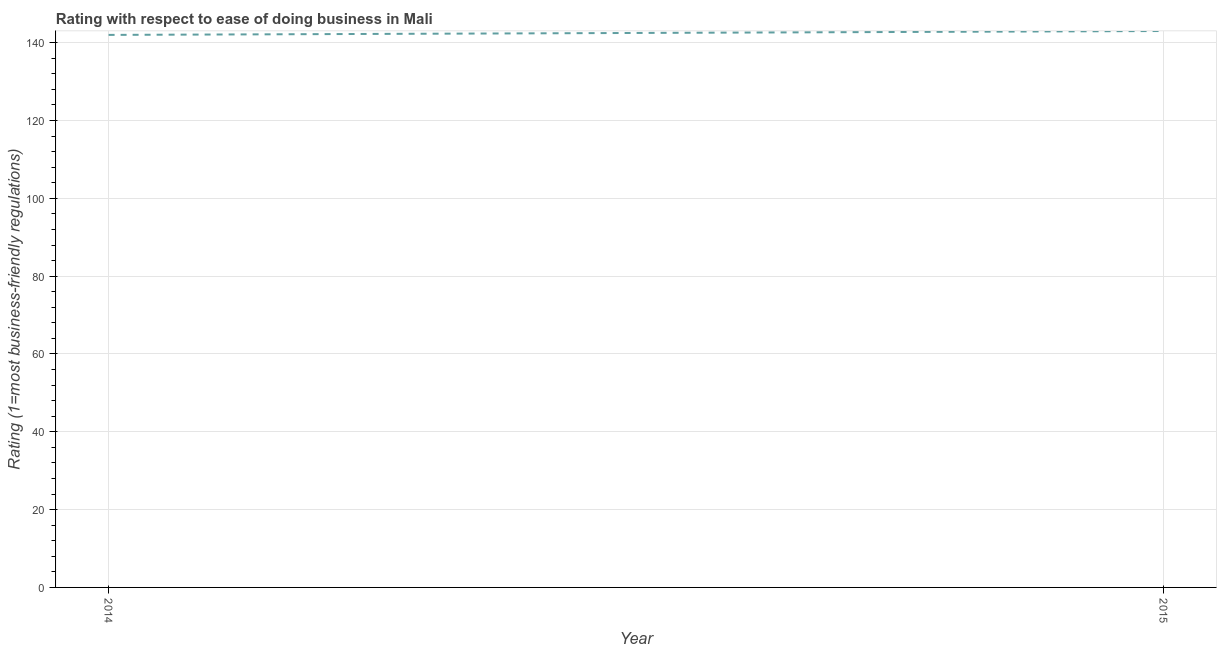What is the ease of doing business index in 2014?
Provide a short and direct response. 142. Across all years, what is the maximum ease of doing business index?
Make the answer very short. 143. Across all years, what is the minimum ease of doing business index?
Ensure brevity in your answer.  142. In which year was the ease of doing business index maximum?
Offer a terse response. 2015. In which year was the ease of doing business index minimum?
Provide a short and direct response. 2014. What is the sum of the ease of doing business index?
Your response must be concise. 285. What is the difference between the ease of doing business index in 2014 and 2015?
Offer a very short reply. -1. What is the average ease of doing business index per year?
Your response must be concise. 142.5. What is the median ease of doing business index?
Ensure brevity in your answer.  142.5. Do a majority of the years between 2015 and 2014 (inclusive) have ease of doing business index greater than 28 ?
Provide a short and direct response. No. What is the ratio of the ease of doing business index in 2014 to that in 2015?
Keep it short and to the point. 0.99. Does the ease of doing business index monotonically increase over the years?
Your response must be concise. Yes. How many lines are there?
Your answer should be very brief. 1. How many years are there in the graph?
Your response must be concise. 2. What is the difference between two consecutive major ticks on the Y-axis?
Make the answer very short. 20. Does the graph contain grids?
Give a very brief answer. Yes. What is the title of the graph?
Keep it short and to the point. Rating with respect to ease of doing business in Mali. What is the label or title of the X-axis?
Keep it short and to the point. Year. What is the label or title of the Y-axis?
Offer a terse response. Rating (1=most business-friendly regulations). What is the Rating (1=most business-friendly regulations) in 2014?
Provide a short and direct response. 142. What is the Rating (1=most business-friendly regulations) in 2015?
Make the answer very short. 143. What is the difference between the Rating (1=most business-friendly regulations) in 2014 and 2015?
Give a very brief answer. -1. What is the ratio of the Rating (1=most business-friendly regulations) in 2014 to that in 2015?
Provide a short and direct response. 0.99. 